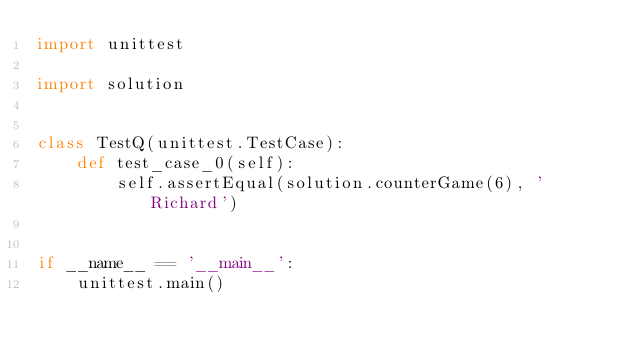<code> <loc_0><loc_0><loc_500><loc_500><_Python_>import unittest

import solution


class TestQ(unittest.TestCase):
    def test_case_0(self):
        self.assertEqual(solution.counterGame(6), 'Richard')


if __name__ == '__main__':
    unittest.main()
</code> 